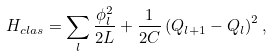<formula> <loc_0><loc_0><loc_500><loc_500>H _ { c l a s } = \sum _ { l } \frac { \phi _ { l } ^ { 2 } } { 2 L } + \frac { 1 } { 2 C } \left ( Q _ { l + 1 } - Q _ { l } \right ) ^ { 2 } ,</formula> 